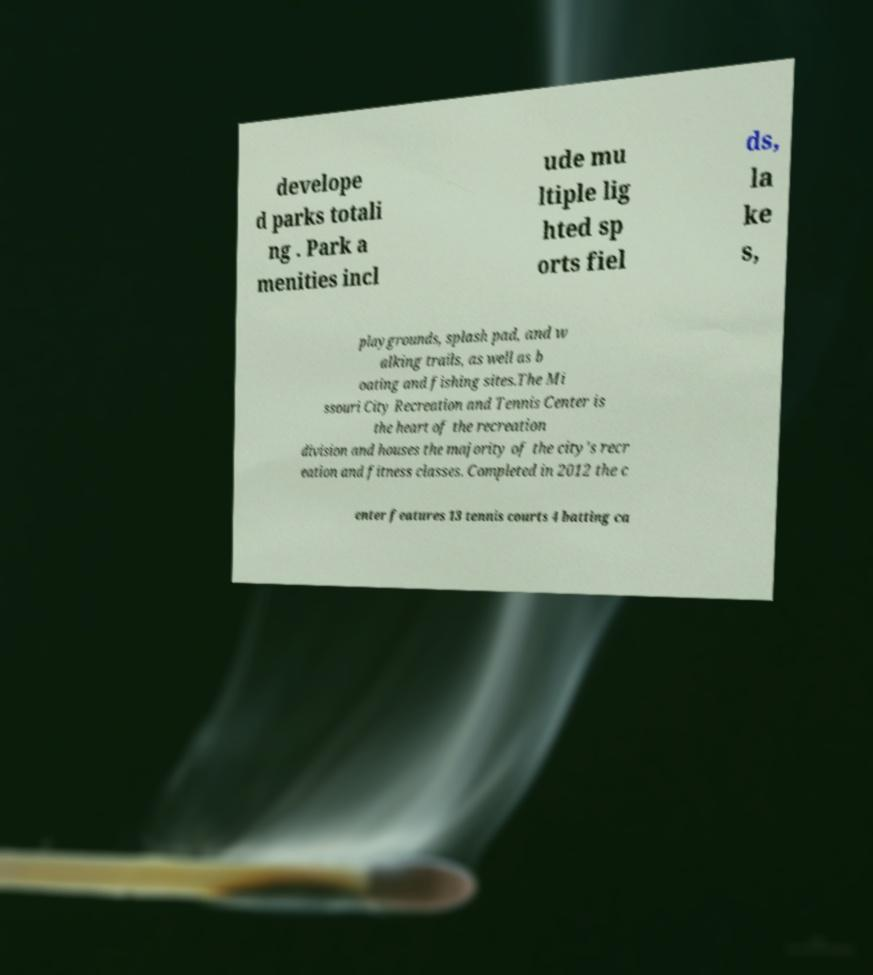Please read and relay the text visible in this image. What does it say? develope d parks totali ng . Park a menities incl ude mu ltiple lig hted sp orts fiel ds, la ke s, playgrounds, splash pad, and w alking trails, as well as b oating and fishing sites.The Mi ssouri City Recreation and Tennis Center is the heart of the recreation division and houses the majority of the city's recr eation and fitness classes. Completed in 2012 the c enter features 13 tennis courts 4 batting ca 